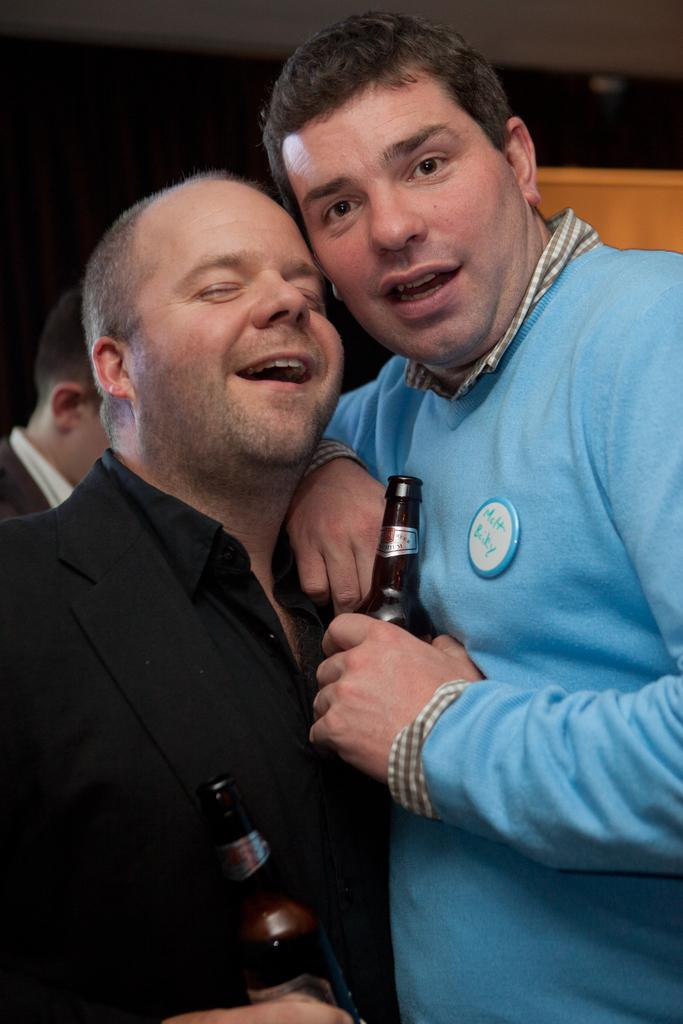How many people are in the image? There are two people in the image. What are the people doing in the image? The people are standing and holding wine bottles. What color are the wine bottles? The wine bottles are black in color. What can be seen in the background of the image? There is a yellow color box in the background of the image. What type of collar can be seen on the wine bottles in the image? There are no collars present on the wine bottles in the image. What material is the marble table made of in the image? There is no marble table present in the image. 